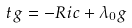Convert formula to latex. <formula><loc_0><loc_0><loc_500><loc_500>\ { t } g = - R i c + \lambda _ { 0 } g</formula> 